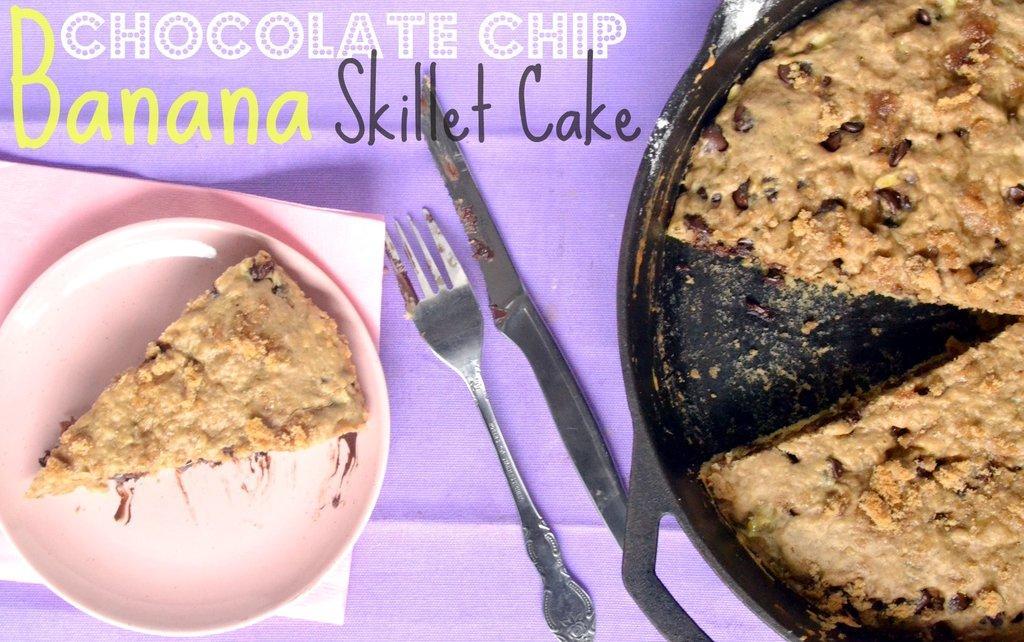Describe this image in one or two sentences. This image consists of a cake. To the left, there is a piece of cake on the the plate. Beside that there is a knife and a fork are kept on a table. At the top, there is a text. 